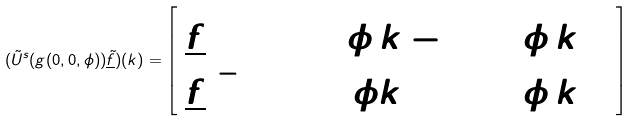Convert formula to latex. <formula><loc_0><loc_0><loc_500><loc_500>( \tilde { U } ^ { s } ( g ( 0 , 0 , \phi ) ) \underline { \tilde { f } } ) ( k ) = \left [ \begin{array} { l } \underline { \tilde { f } } ^ { ( + ) } ( \cosh \phi \, k - \sinh \phi \, { k ^ { 0 } } ) \\ \underline { \tilde { f } } ^ { ( - ) } ( \cosh \, \phi k + \sinh \phi \, { k ^ { 0 } } ) \end{array} \right ]</formula> 